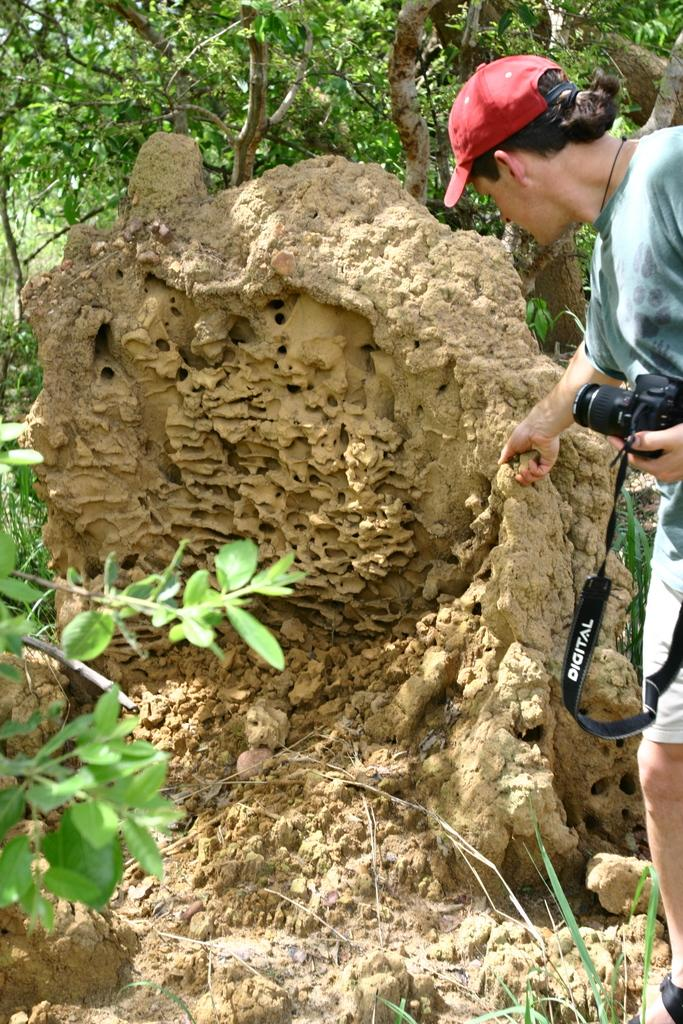What is the person in the image doing? The person is standing in the image and holding a camera. What can be seen on the left side of the image? There is a plant on the left side of the image. What is visible in the background of the image? There are trees visible in the background of the image. What type of fact card is the person holding in the image? There is no fact card present in the image; the person is holding a camera. What is the person wearing on their wrist in the image? There is no information about the person's wristwear in the image. 